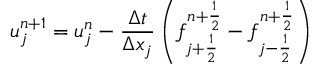<formula> <loc_0><loc_0><loc_500><loc_500>u _ { j } ^ { n + 1 } = u _ { j } ^ { n } - \frac { \Delta t } { \Delta x _ { j } } \left ( f _ { j + \frac { 1 } { 2 } } ^ { n + \frac { 1 } { 2 } } - f _ { j - \frac { 1 } { 2 } } ^ { n + \frac { 1 } { 2 } } \right )</formula> 